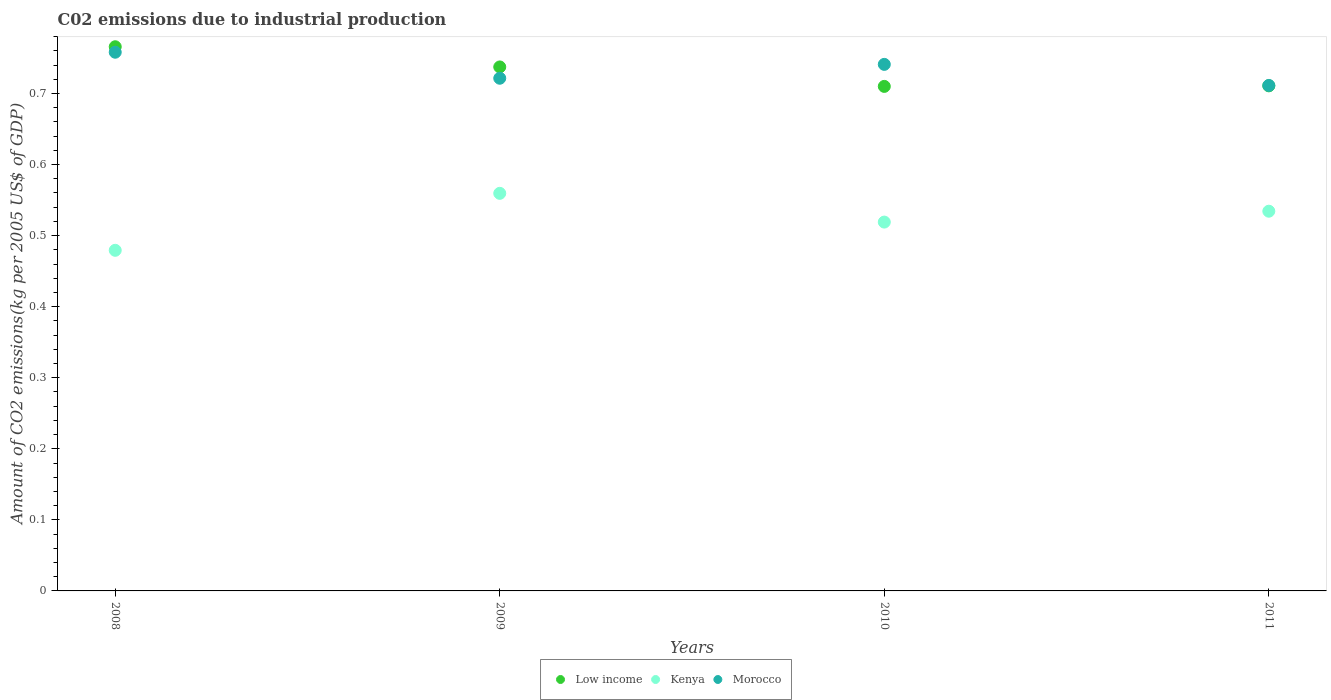How many different coloured dotlines are there?
Keep it short and to the point. 3. What is the amount of CO2 emitted due to industrial production in Morocco in 2010?
Offer a very short reply. 0.74. Across all years, what is the maximum amount of CO2 emitted due to industrial production in Kenya?
Offer a terse response. 0.56. Across all years, what is the minimum amount of CO2 emitted due to industrial production in Low income?
Your response must be concise. 0.71. What is the total amount of CO2 emitted due to industrial production in Low income in the graph?
Your answer should be compact. 2.92. What is the difference between the amount of CO2 emitted due to industrial production in Low income in 2008 and that in 2010?
Ensure brevity in your answer.  0.06. What is the difference between the amount of CO2 emitted due to industrial production in Morocco in 2008 and the amount of CO2 emitted due to industrial production in Low income in 2010?
Provide a short and direct response. 0.05. What is the average amount of CO2 emitted due to industrial production in Morocco per year?
Offer a very short reply. 0.73. In the year 2011, what is the difference between the amount of CO2 emitted due to industrial production in Low income and amount of CO2 emitted due to industrial production in Morocco?
Your answer should be very brief. -0. In how many years, is the amount of CO2 emitted due to industrial production in Low income greater than 0.38000000000000006 kg?
Keep it short and to the point. 4. What is the ratio of the amount of CO2 emitted due to industrial production in Low income in 2008 to that in 2010?
Offer a terse response. 1.08. Is the amount of CO2 emitted due to industrial production in Kenya in 2010 less than that in 2011?
Offer a terse response. Yes. What is the difference between the highest and the second highest amount of CO2 emitted due to industrial production in Kenya?
Give a very brief answer. 0.03. What is the difference between the highest and the lowest amount of CO2 emitted due to industrial production in Kenya?
Provide a succinct answer. 0.08. Is the amount of CO2 emitted due to industrial production in Low income strictly greater than the amount of CO2 emitted due to industrial production in Morocco over the years?
Offer a very short reply. No. How many dotlines are there?
Offer a very short reply. 3. What is the difference between two consecutive major ticks on the Y-axis?
Your response must be concise. 0.1. Does the graph contain any zero values?
Your answer should be compact. No. Where does the legend appear in the graph?
Make the answer very short. Bottom center. What is the title of the graph?
Keep it short and to the point. C02 emissions due to industrial production. Does "Colombia" appear as one of the legend labels in the graph?
Offer a very short reply. No. What is the label or title of the X-axis?
Provide a succinct answer. Years. What is the label or title of the Y-axis?
Keep it short and to the point. Amount of CO2 emissions(kg per 2005 US$ of GDP). What is the Amount of CO2 emissions(kg per 2005 US$ of GDP) of Low income in 2008?
Your answer should be very brief. 0.77. What is the Amount of CO2 emissions(kg per 2005 US$ of GDP) of Kenya in 2008?
Your answer should be very brief. 0.48. What is the Amount of CO2 emissions(kg per 2005 US$ of GDP) in Morocco in 2008?
Make the answer very short. 0.76. What is the Amount of CO2 emissions(kg per 2005 US$ of GDP) in Low income in 2009?
Keep it short and to the point. 0.74. What is the Amount of CO2 emissions(kg per 2005 US$ of GDP) of Kenya in 2009?
Provide a short and direct response. 0.56. What is the Amount of CO2 emissions(kg per 2005 US$ of GDP) in Morocco in 2009?
Make the answer very short. 0.72. What is the Amount of CO2 emissions(kg per 2005 US$ of GDP) in Low income in 2010?
Your answer should be very brief. 0.71. What is the Amount of CO2 emissions(kg per 2005 US$ of GDP) in Kenya in 2010?
Your answer should be compact. 0.52. What is the Amount of CO2 emissions(kg per 2005 US$ of GDP) of Morocco in 2010?
Keep it short and to the point. 0.74. What is the Amount of CO2 emissions(kg per 2005 US$ of GDP) in Low income in 2011?
Keep it short and to the point. 0.71. What is the Amount of CO2 emissions(kg per 2005 US$ of GDP) in Kenya in 2011?
Provide a short and direct response. 0.53. What is the Amount of CO2 emissions(kg per 2005 US$ of GDP) of Morocco in 2011?
Offer a very short reply. 0.71. Across all years, what is the maximum Amount of CO2 emissions(kg per 2005 US$ of GDP) in Low income?
Make the answer very short. 0.77. Across all years, what is the maximum Amount of CO2 emissions(kg per 2005 US$ of GDP) of Kenya?
Your response must be concise. 0.56. Across all years, what is the maximum Amount of CO2 emissions(kg per 2005 US$ of GDP) in Morocco?
Your answer should be compact. 0.76. Across all years, what is the minimum Amount of CO2 emissions(kg per 2005 US$ of GDP) of Low income?
Keep it short and to the point. 0.71. Across all years, what is the minimum Amount of CO2 emissions(kg per 2005 US$ of GDP) in Kenya?
Ensure brevity in your answer.  0.48. Across all years, what is the minimum Amount of CO2 emissions(kg per 2005 US$ of GDP) in Morocco?
Your answer should be very brief. 0.71. What is the total Amount of CO2 emissions(kg per 2005 US$ of GDP) of Low income in the graph?
Your answer should be very brief. 2.92. What is the total Amount of CO2 emissions(kg per 2005 US$ of GDP) of Kenya in the graph?
Your answer should be compact. 2.09. What is the total Amount of CO2 emissions(kg per 2005 US$ of GDP) of Morocco in the graph?
Keep it short and to the point. 2.93. What is the difference between the Amount of CO2 emissions(kg per 2005 US$ of GDP) in Low income in 2008 and that in 2009?
Keep it short and to the point. 0.03. What is the difference between the Amount of CO2 emissions(kg per 2005 US$ of GDP) of Kenya in 2008 and that in 2009?
Give a very brief answer. -0.08. What is the difference between the Amount of CO2 emissions(kg per 2005 US$ of GDP) of Morocco in 2008 and that in 2009?
Your answer should be compact. 0.04. What is the difference between the Amount of CO2 emissions(kg per 2005 US$ of GDP) of Low income in 2008 and that in 2010?
Offer a very short reply. 0.06. What is the difference between the Amount of CO2 emissions(kg per 2005 US$ of GDP) of Kenya in 2008 and that in 2010?
Your answer should be very brief. -0.04. What is the difference between the Amount of CO2 emissions(kg per 2005 US$ of GDP) in Morocco in 2008 and that in 2010?
Offer a terse response. 0.02. What is the difference between the Amount of CO2 emissions(kg per 2005 US$ of GDP) in Low income in 2008 and that in 2011?
Provide a succinct answer. 0.06. What is the difference between the Amount of CO2 emissions(kg per 2005 US$ of GDP) in Kenya in 2008 and that in 2011?
Offer a terse response. -0.06. What is the difference between the Amount of CO2 emissions(kg per 2005 US$ of GDP) in Morocco in 2008 and that in 2011?
Keep it short and to the point. 0.05. What is the difference between the Amount of CO2 emissions(kg per 2005 US$ of GDP) of Low income in 2009 and that in 2010?
Provide a succinct answer. 0.03. What is the difference between the Amount of CO2 emissions(kg per 2005 US$ of GDP) in Kenya in 2009 and that in 2010?
Keep it short and to the point. 0.04. What is the difference between the Amount of CO2 emissions(kg per 2005 US$ of GDP) of Morocco in 2009 and that in 2010?
Provide a short and direct response. -0.02. What is the difference between the Amount of CO2 emissions(kg per 2005 US$ of GDP) of Low income in 2009 and that in 2011?
Give a very brief answer. 0.03. What is the difference between the Amount of CO2 emissions(kg per 2005 US$ of GDP) of Kenya in 2009 and that in 2011?
Ensure brevity in your answer.  0.03. What is the difference between the Amount of CO2 emissions(kg per 2005 US$ of GDP) of Morocco in 2009 and that in 2011?
Offer a terse response. 0.01. What is the difference between the Amount of CO2 emissions(kg per 2005 US$ of GDP) in Low income in 2010 and that in 2011?
Give a very brief answer. -0. What is the difference between the Amount of CO2 emissions(kg per 2005 US$ of GDP) in Kenya in 2010 and that in 2011?
Keep it short and to the point. -0.02. What is the difference between the Amount of CO2 emissions(kg per 2005 US$ of GDP) in Morocco in 2010 and that in 2011?
Make the answer very short. 0.03. What is the difference between the Amount of CO2 emissions(kg per 2005 US$ of GDP) in Low income in 2008 and the Amount of CO2 emissions(kg per 2005 US$ of GDP) in Kenya in 2009?
Make the answer very short. 0.21. What is the difference between the Amount of CO2 emissions(kg per 2005 US$ of GDP) in Low income in 2008 and the Amount of CO2 emissions(kg per 2005 US$ of GDP) in Morocco in 2009?
Make the answer very short. 0.04. What is the difference between the Amount of CO2 emissions(kg per 2005 US$ of GDP) in Kenya in 2008 and the Amount of CO2 emissions(kg per 2005 US$ of GDP) in Morocco in 2009?
Keep it short and to the point. -0.24. What is the difference between the Amount of CO2 emissions(kg per 2005 US$ of GDP) of Low income in 2008 and the Amount of CO2 emissions(kg per 2005 US$ of GDP) of Kenya in 2010?
Offer a very short reply. 0.25. What is the difference between the Amount of CO2 emissions(kg per 2005 US$ of GDP) in Low income in 2008 and the Amount of CO2 emissions(kg per 2005 US$ of GDP) in Morocco in 2010?
Provide a succinct answer. 0.02. What is the difference between the Amount of CO2 emissions(kg per 2005 US$ of GDP) of Kenya in 2008 and the Amount of CO2 emissions(kg per 2005 US$ of GDP) of Morocco in 2010?
Provide a succinct answer. -0.26. What is the difference between the Amount of CO2 emissions(kg per 2005 US$ of GDP) of Low income in 2008 and the Amount of CO2 emissions(kg per 2005 US$ of GDP) of Kenya in 2011?
Make the answer very short. 0.23. What is the difference between the Amount of CO2 emissions(kg per 2005 US$ of GDP) of Low income in 2008 and the Amount of CO2 emissions(kg per 2005 US$ of GDP) of Morocco in 2011?
Ensure brevity in your answer.  0.05. What is the difference between the Amount of CO2 emissions(kg per 2005 US$ of GDP) of Kenya in 2008 and the Amount of CO2 emissions(kg per 2005 US$ of GDP) of Morocco in 2011?
Offer a very short reply. -0.23. What is the difference between the Amount of CO2 emissions(kg per 2005 US$ of GDP) of Low income in 2009 and the Amount of CO2 emissions(kg per 2005 US$ of GDP) of Kenya in 2010?
Give a very brief answer. 0.22. What is the difference between the Amount of CO2 emissions(kg per 2005 US$ of GDP) of Low income in 2009 and the Amount of CO2 emissions(kg per 2005 US$ of GDP) of Morocco in 2010?
Give a very brief answer. -0. What is the difference between the Amount of CO2 emissions(kg per 2005 US$ of GDP) in Kenya in 2009 and the Amount of CO2 emissions(kg per 2005 US$ of GDP) in Morocco in 2010?
Make the answer very short. -0.18. What is the difference between the Amount of CO2 emissions(kg per 2005 US$ of GDP) in Low income in 2009 and the Amount of CO2 emissions(kg per 2005 US$ of GDP) in Kenya in 2011?
Make the answer very short. 0.2. What is the difference between the Amount of CO2 emissions(kg per 2005 US$ of GDP) of Low income in 2009 and the Amount of CO2 emissions(kg per 2005 US$ of GDP) of Morocco in 2011?
Your answer should be compact. 0.03. What is the difference between the Amount of CO2 emissions(kg per 2005 US$ of GDP) of Kenya in 2009 and the Amount of CO2 emissions(kg per 2005 US$ of GDP) of Morocco in 2011?
Ensure brevity in your answer.  -0.15. What is the difference between the Amount of CO2 emissions(kg per 2005 US$ of GDP) in Low income in 2010 and the Amount of CO2 emissions(kg per 2005 US$ of GDP) in Kenya in 2011?
Provide a succinct answer. 0.18. What is the difference between the Amount of CO2 emissions(kg per 2005 US$ of GDP) in Low income in 2010 and the Amount of CO2 emissions(kg per 2005 US$ of GDP) in Morocco in 2011?
Keep it short and to the point. -0. What is the difference between the Amount of CO2 emissions(kg per 2005 US$ of GDP) in Kenya in 2010 and the Amount of CO2 emissions(kg per 2005 US$ of GDP) in Morocco in 2011?
Provide a succinct answer. -0.19. What is the average Amount of CO2 emissions(kg per 2005 US$ of GDP) in Low income per year?
Offer a very short reply. 0.73. What is the average Amount of CO2 emissions(kg per 2005 US$ of GDP) of Kenya per year?
Give a very brief answer. 0.52. What is the average Amount of CO2 emissions(kg per 2005 US$ of GDP) in Morocco per year?
Give a very brief answer. 0.73. In the year 2008, what is the difference between the Amount of CO2 emissions(kg per 2005 US$ of GDP) in Low income and Amount of CO2 emissions(kg per 2005 US$ of GDP) in Kenya?
Give a very brief answer. 0.29. In the year 2008, what is the difference between the Amount of CO2 emissions(kg per 2005 US$ of GDP) in Low income and Amount of CO2 emissions(kg per 2005 US$ of GDP) in Morocco?
Your answer should be very brief. 0.01. In the year 2008, what is the difference between the Amount of CO2 emissions(kg per 2005 US$ of GDP) of Kenya and Amount of CO2 emissions(kg per 2005 US$ of GDP) of Morocco?
Make the answer very short. -0.28. In the year 2009, what is the difference between the Amount of CO2 emissions(kg per 2005 US$ of GDP) in Low income and Amount of CO2 emissions(kg per 2005 US$ of GDP) in Kenya?
Provide a succinct answer. 0.18. In the year 2009, what is the difference between the Amount of CO2 emissions(kg per 2005 US$ of GDP) in Low income and Amount of CO2 emissions(kg per 2005 US$ of GDP) in Morocco?
Your answer should be very brief. 0.02. In the year 2009, what is the difference between the Amount of CO2 emissions(kg per 2005 US$ of GDP) in Kenya and Amount of CO2 emissions(kg per 2005 US$ of GDP) in Morocco?
Keep it short and to the point. -0.16. In the year 2010, what is the difference between the Amount of CO2 emissions(kg per 2005 US$ of GDP) of Low income and Amount of CO2 emissions(kg per 2005 US$ of GDP) of Kenya?
Your response must be concise. 0.19. In the year 2010, what is the difference between the Amount of CO2 emissions(kg per 2005 US$ of GDP) of Low income and Amount of CO2 emissions(kg per 2005 US$ of GDP) of Morocco?
Give a very brief answer. -0.03. In the year 2010, what is the difference between the Amount of CO2 emissions(kg per 2005 US$ of GDP) of Kenya and Amount of CO2 emissions(kg per 2005 US$ of GDP) of Morocco?
Keep it short and to the point. -0.22. In the year 2011, what is the difference between the Amount of CO2 emissions(kg per 2005 US$ of GDP) of Low income and Amount of CO2 emissions(kg per 2005 US$ of GDP) of Kenya?
Ensure brevity in your answer.  0.18. In the year 2011, what is the difference between the Amount of CO2 emissions(kg per 2005 US$ of GDP) of Low income and Amount of CO2 emissions(kg per 2005 US$ of GDP) of Morocco?
Keep it short and to the point. -0. In the year 2011, what is the difference between the Amount of CO2 emissions(kg per 2005 US$ of GDP) of Kenya and Amount of CO2 emissions(kg per 2005 US$ of GDP) of Morocco?
Keep it short and to the point. -0.18. What is the ratio of the Amount of CO2 emissions(kg per 2005 US$ of GDP) in Low income in 2008 to that in 2009?
Your answer should be very brief. 1.04. What is the ratio of the Amount of CO2 emissions(kg per 2005 US$ of GDP) of Kenya in 2008 to that in 2009?
Your response must be concise. 0.86. What is the ratio of the Amount of CO2 emissions(kg per 2005 US$ of GDP) of Morocco in 2008 to that in 2009?
Give a very brief answer. 1.05. What is the ratio of the Amount of CO2 emissions(kg per 2005 US$ of GDP) of Low income in 2008 to that in 2010?
Ensure brevity in your answer.  1.08. What is the ratio of the Amount of CO2 emissions(kg per 2005 US$ of GDP) in Kenya in 2008 to that in 2010?
Offer a terse response. 0.92. What is the ratio of the Amount of CO2 emissions(kg per 2005 US$ of GDP) of Morocco in 2008 to that in 2010?
Provide a succinct answer. 1.02. What is the ratio of the Amount of CO2 emissions(kg per 2005 US$ of GDP) of Low income in 2008 to that in 2011?
Offer a terse response. 1.08. What is the ratio of the Amount of CO2 emissions(kg per 2005 US$ of GDP) of Kenya in 2008 to that in 2011?
Provide a short and direct response. 0.9. What is the ratio of the Amount of CO2 emissions(kg per 2005 US$ of GDP) in Morocco in 2008 to that in 2011?
Provide a succinct answer. 1.07. What is the ratio of the Amount of CO2 emissions(kg per 2005 US$ of GDP) of Low income in 2009 to that in 2010?
Ensure brevity in your answer.  1.04. What is the ratio of the Amount of CO2 emissions(kg per 2005 US$ of GDP) of Kenya in 2009 to that in 2010?
Make the answer very short. 1.08. What is the ratio of the Amount of CO2 emissions(kg per 2005 US$ of GDP) in Morocco in 2009 to that in 2010?
Offer a very short reply. 0.97. What is the ratio of the Amount of CO2 emissions(kg per 2005 US$ of GDP) of Low income in 2009 to that in 2011?
Your response must be concise. 1.04. What is the ratio of the Amount of CO2 emissions(kg per 2005 US$ of GDP) in Kenya in 2009 to that in 2011?
Offer a very short reply. 1.05. What is the ratio of the Amount of CO2 emissions(kg per 2005 US$ of GDP) of Morocco in 2009 to that in 2011?
Provide a short and direct response. 1.01. What is the ratio of the Amount of CO2 emissions(kg per 2005 US$ of GDP) in Kenya in 2010 to that in 2011?
Provide a short and direct response. 0.97. What is the ratio of the Amount of CO2 emissions(kg per 2005 US$ of GDP) in Morocco in 2010 to that in 2011?
Provide a short and direct response. 1.04. What is the difference between the highest and the second highest Amount of CO2 emissions(kg per 2005 US$ of GDP) in Low income?
Make the answer very short. 0.03. What is the difference between the highest and the second highest Amount of CO2 emissions(kg per 2005 US$ of GDP) in Kenya?
Give a very brief answer. 0.03. What is the difference between the highest and the second highest Amount of CO2 emissions(kg per 2005 US$ of GDP) of Morocco?
Give a very brief answer. 0.02. What is the difference between the highest and the lowest Amount of CO2 emissions(kg per 2005 US$ of GDP) of Low income?
Your answer should be very brief. 0.06. What is the difference between the highest and the lowest Amount of CO2 emissions(kg per 2005 US$ of GDP) in Kenya?
Provide a short and direct response. 0.08. What is the difference between the highest and the lowest Amount of CO2 emissions(kg per 2005 US$ of GDP) of Morocco?
Offer a terse response. 0.05. 